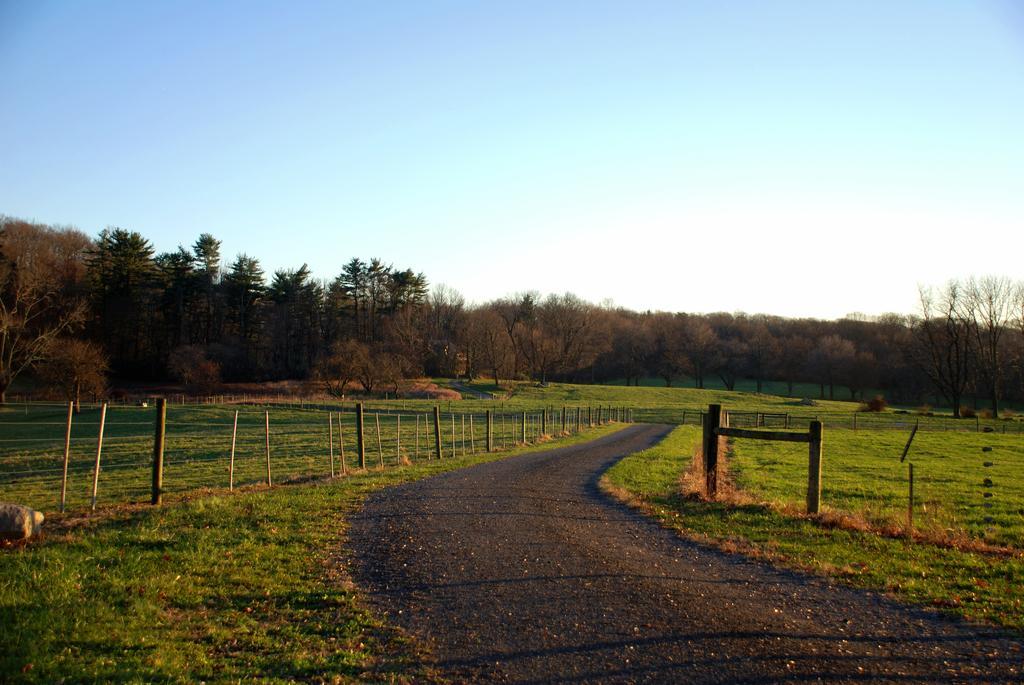How would you summarize this image in a sentence or two? In this image we can see some trees, plants, and the grass, there are rocks, wooden poles, also we can see the sky. 